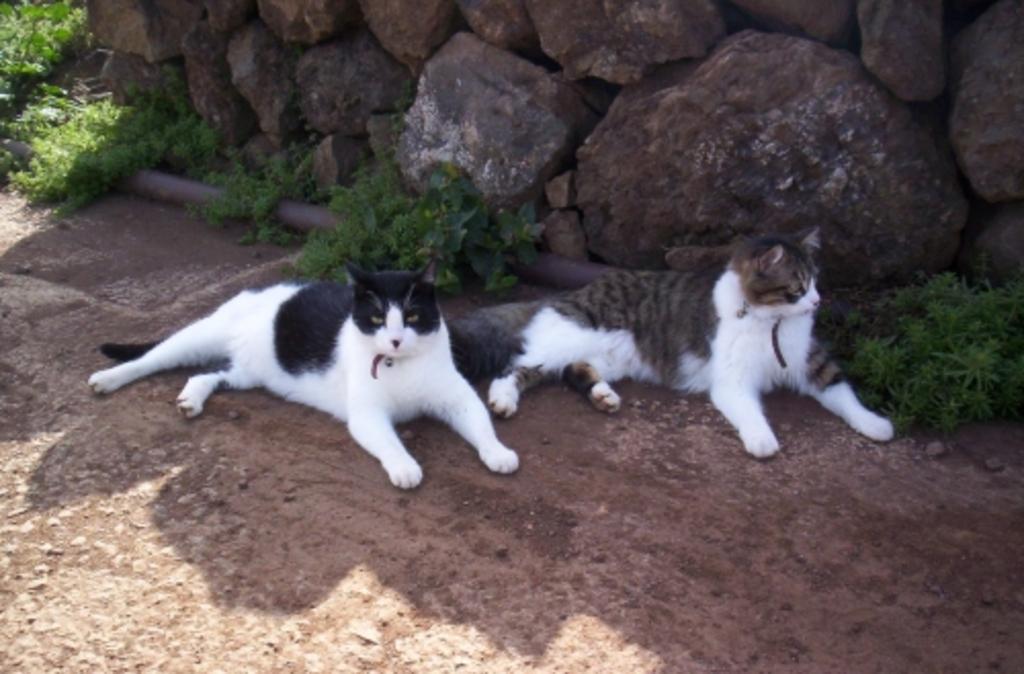Please provide a concise description of this image. In This image in the center there are two cats, in the background there are some rocks and plants. At the bottom there is a walkway. 